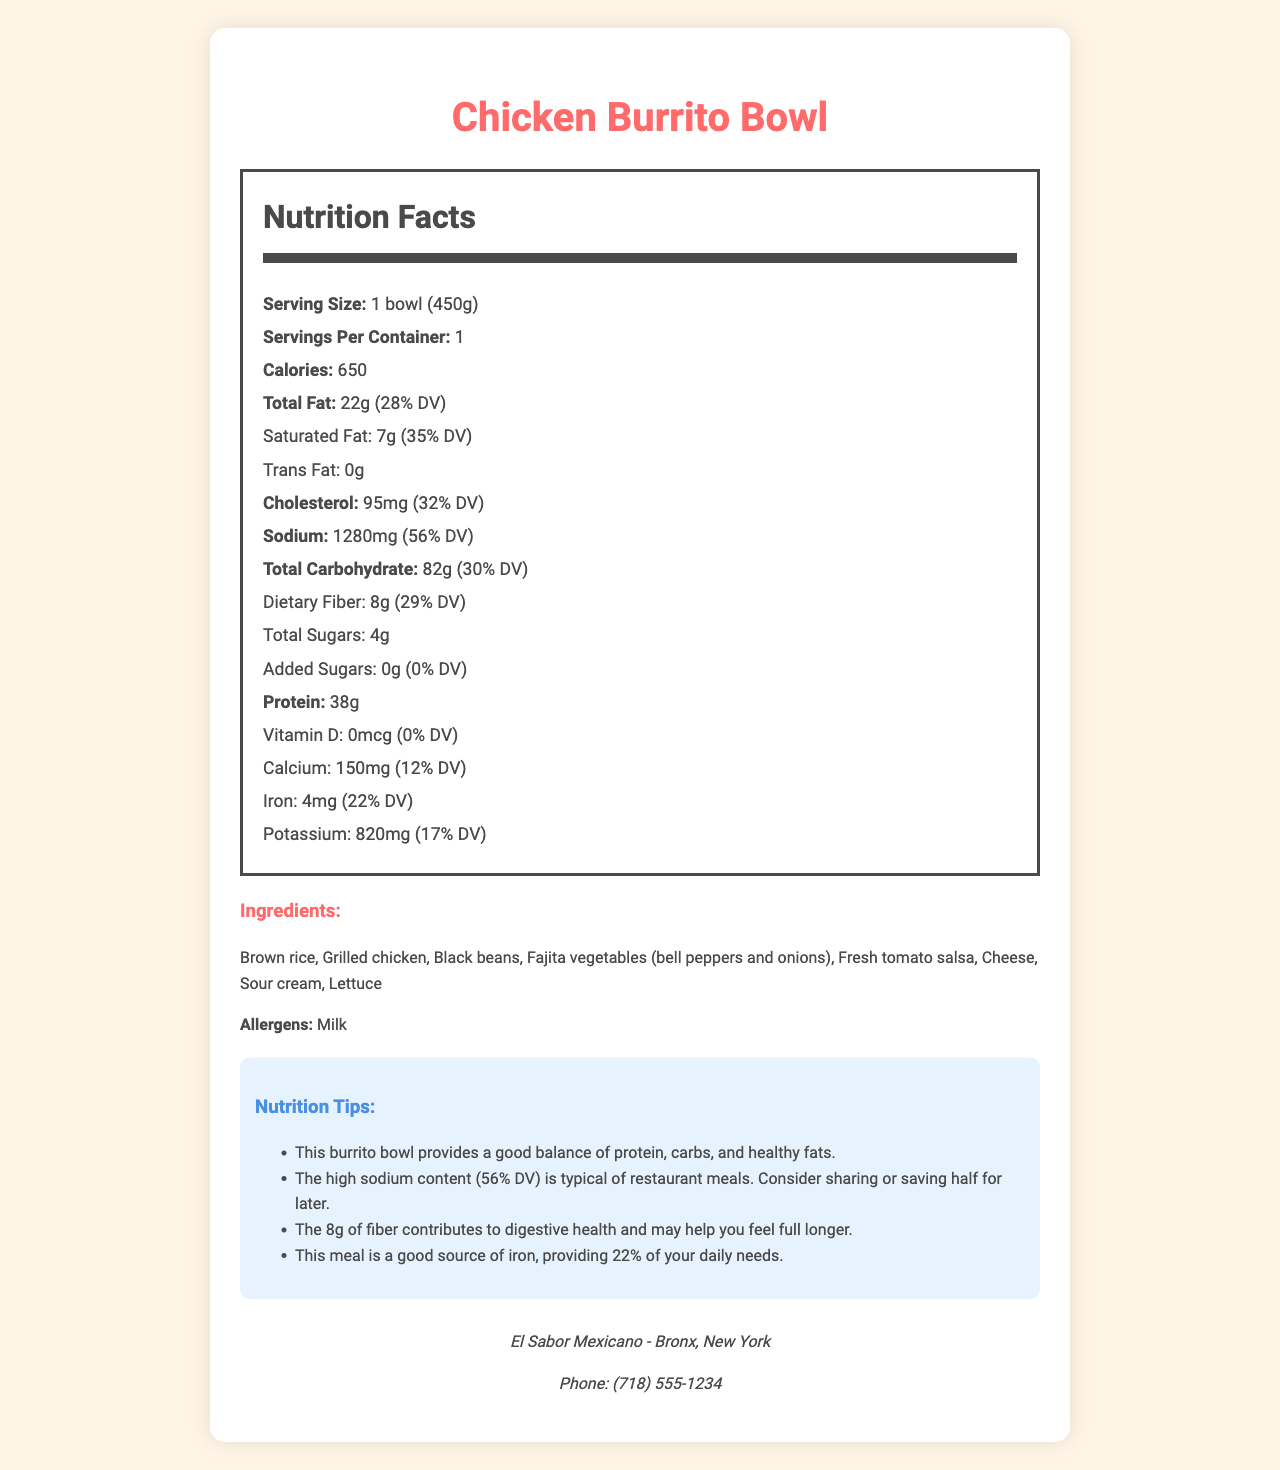what is the serving size for the Chicken Burrito Bowl? The serving size is mentioned at the top of the Nutrition Facts section as "Serving Size: 1 bowl (450g)".
Answer: 1 bowl (450g) how many calories are in one serving of the Chicken Burrito Bowl? The calories are listed in the Nutrition Facts section as "Calories: 650".
Answer: 650 what is the amount of protein in the Chicken Burrito Bowl? The amount of protein is specified in the Nutrition Facts section as "Protein: 38g".
Answer: 38g what is the daily value percentage for saturated fat in this dish? The daily value percentage for saturated fat is shown in the Nutrition Facts section as "Saturated Fat: 7g (35% DV)".
Answer: 35% how much dietary fiber does the Chicken Burrito Bowl contain? The amount of dietary fiber is specified in the Nutrition Facts section as "Dietary Fiber: 8g (29% DV)".
Answer: 8g does this dish contain any trans fat? The Nutrition Facts section states "Trans Fat: 0g", indicating that there is no trans fat in this dish.
Answer: No which nutrient has the highest daily value percentage in the Chicken Burrito Bowl? A. Sodium B. Protein C. Cholesterol D. Fiber Sodium has the highest daily value percentage at 56% DV, compared to protein (76%), cholesterol (32%), and fiber (29%).
Answer: A what are the main ingredients of this dish? A. Brown rice, Grilled chicken, Black beans, Fajita vegetables B. Fresh tomato salsa, Cheese, Sour cream, Lettuce C. Both A and B Both sets of options A and B together make up the main ingredients of the dish.
Answer: C can you reduce the calorie content of the Chicken Burrito Bowl by changing the ingredients? According to the employee notes, customers can reduce calories by opting for no cheese or sour cream, or by requesting extra vegetables instead of rice.
Answer: Yes does the nutrition label mention the amount of vitamin D in the Chicken Burrito Bowl? The amount of vitamin D is listed as 0mcg with 0% DV.
Answer: Yes what is the cholesterol content in the Chicken Burrito Bowl? The cholesterol content is mentioned in the Nutrition Facts section as "Cholesterol: 95mg (32% DV)".
Answer: 95mg describe the nutrition content and tips provided for the Chicken Burrito Bowl. The document gives a detailed breakdown of the nutritional content of the Chicken Burrito Bowl along with tips for consumption: balancing macronutrients, considering the high sodium content, the benefits of dietary fiber, and the iron contribution.
Answer: The Chicken Burrito Bowl has a serving size of 1 bowl (450g) with 650 calories. It contains 22g of total fat, 7g of saturated fat, 0g of trans fat, 95mg of cholesterol, 1280mg of sodium, 82g of total carbohydrates, 8g of dietary fiber, 4g of total sugars, 0g of added sugars, and 38g of protein. Nutritional tips include balancing protein, carbs, and fats, high sodium content, fiber benefits, and the iron source. how can customers contact the restaurant? The restaurant info section provides the phone number to contact the restaurant.
Answer: (718) 555-1234 what percentage of the daily value of calcium does the Chicken Burrito Bowl provide? The Nutrition Facts section lists the calcium content as "Calcium: 150mg (12% DV)".
Answer: 12% does the document mention how many calories come from added sugars? The document only mentions the amount of added sugars (0g) and not any specific calorie breakdown from them.
Answer: No 